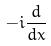Convert formula to latex. <formula><loc_0><loc_0><loc_500><loc_500>- i \frac { d } { d x }</formula> 